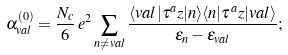<formula> <loc_0><loc_0><loc_500><loc_500>\alpha _ { v a l } ^ { ( 0 ) } = { \frac { N _ { c } } { 6 } } \, e ^ { 2 } \sum _ { n \ne v a l } { \frac { \langle v a l | \tau ^ { a } z | n \rangle \langle n | \tau ^ { a } z | v a l \rangle } { \epsilon _ { n } - \epsilon _ { v a l } } } ;</formula> 